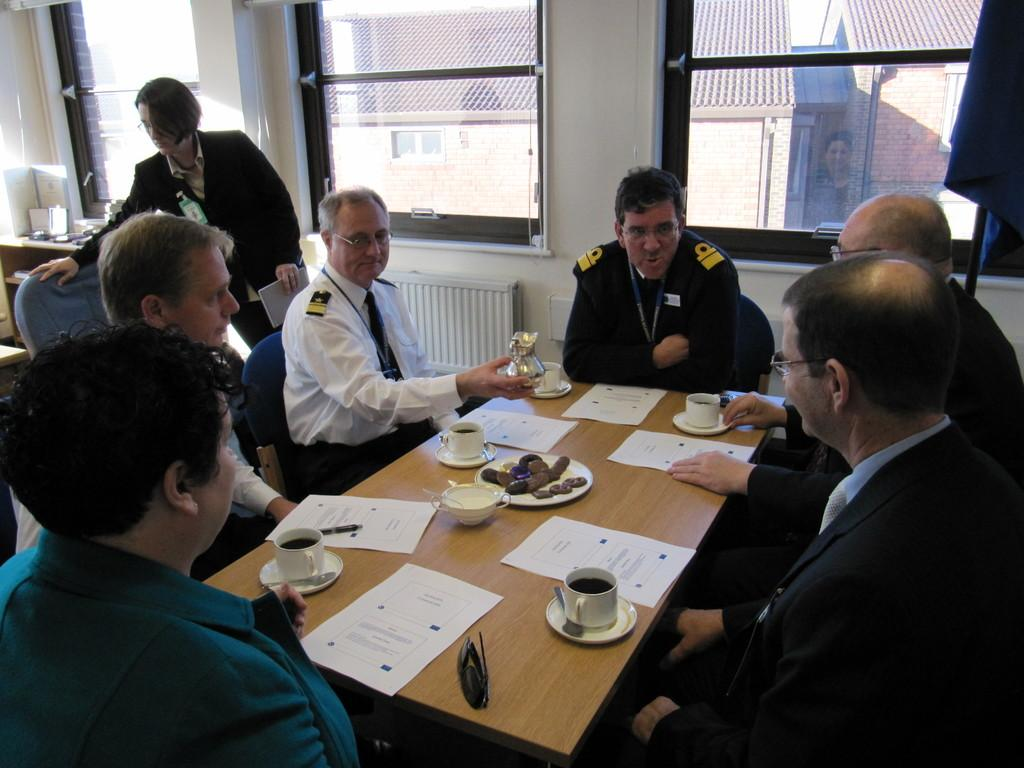What are the people in the image doing? The people in the image are sitting on chairs. Where are the people sitting in relation to the tables? The people are sitting in front of the tables. What can be seen on the tables? There are objects placed on the tables. Can you describe the woman in the image? There is a woman visible in the image. What is visible in the background of the image? There are two windows in the background. Can you tell me how many cows are running in the image? There are no cows present in the image, and therefore no running cows can be observed. 